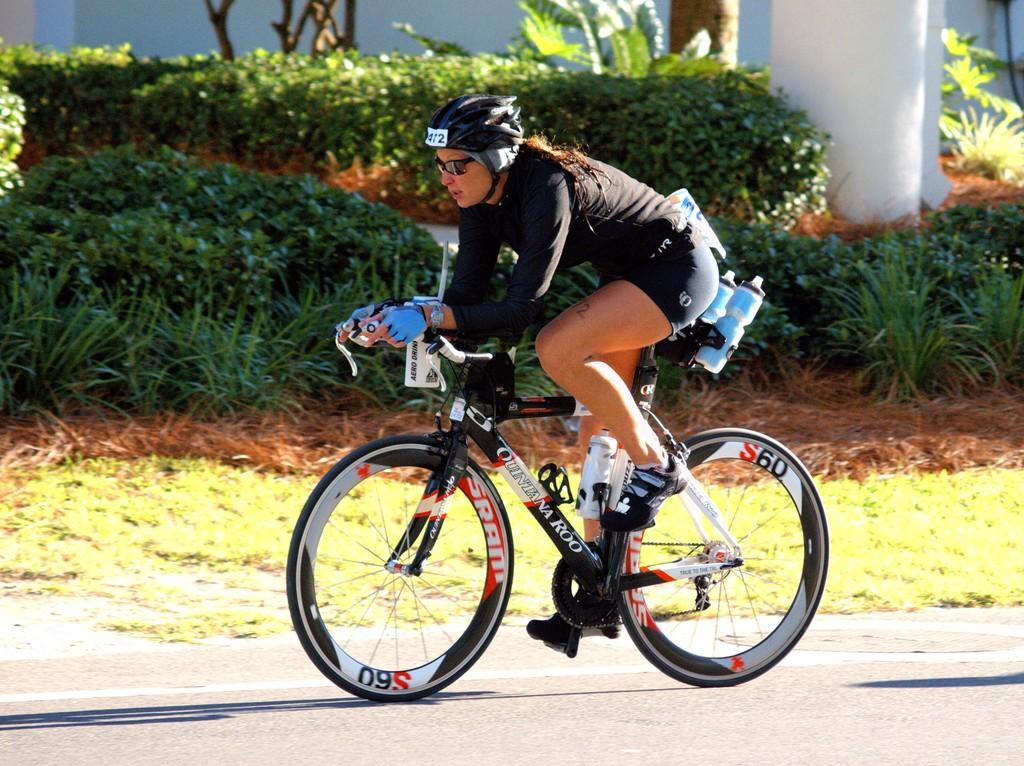What is the woman in the image wearing on her head? The woman is wearing a helmet in the image. What is the woman wearing to protect her eyes? The woman is wearing goggles in the image. What type of footwear is the woman wearing? The woman is wearing shoes in the image. What is the woman wearing on her hands? The woman is wearing gloves in the image. What is the woman doing in the image? The woman is riding a bicycle in the image. Where is the bicycle located? The bicycle is on the road in the image. What can be seen in the background of the image? There are trees in the background of the image. What type of wool is being used to make the stew in the image? There is no stew present in the image, so it is not possible to determine what type of wool might be used in a stew. 